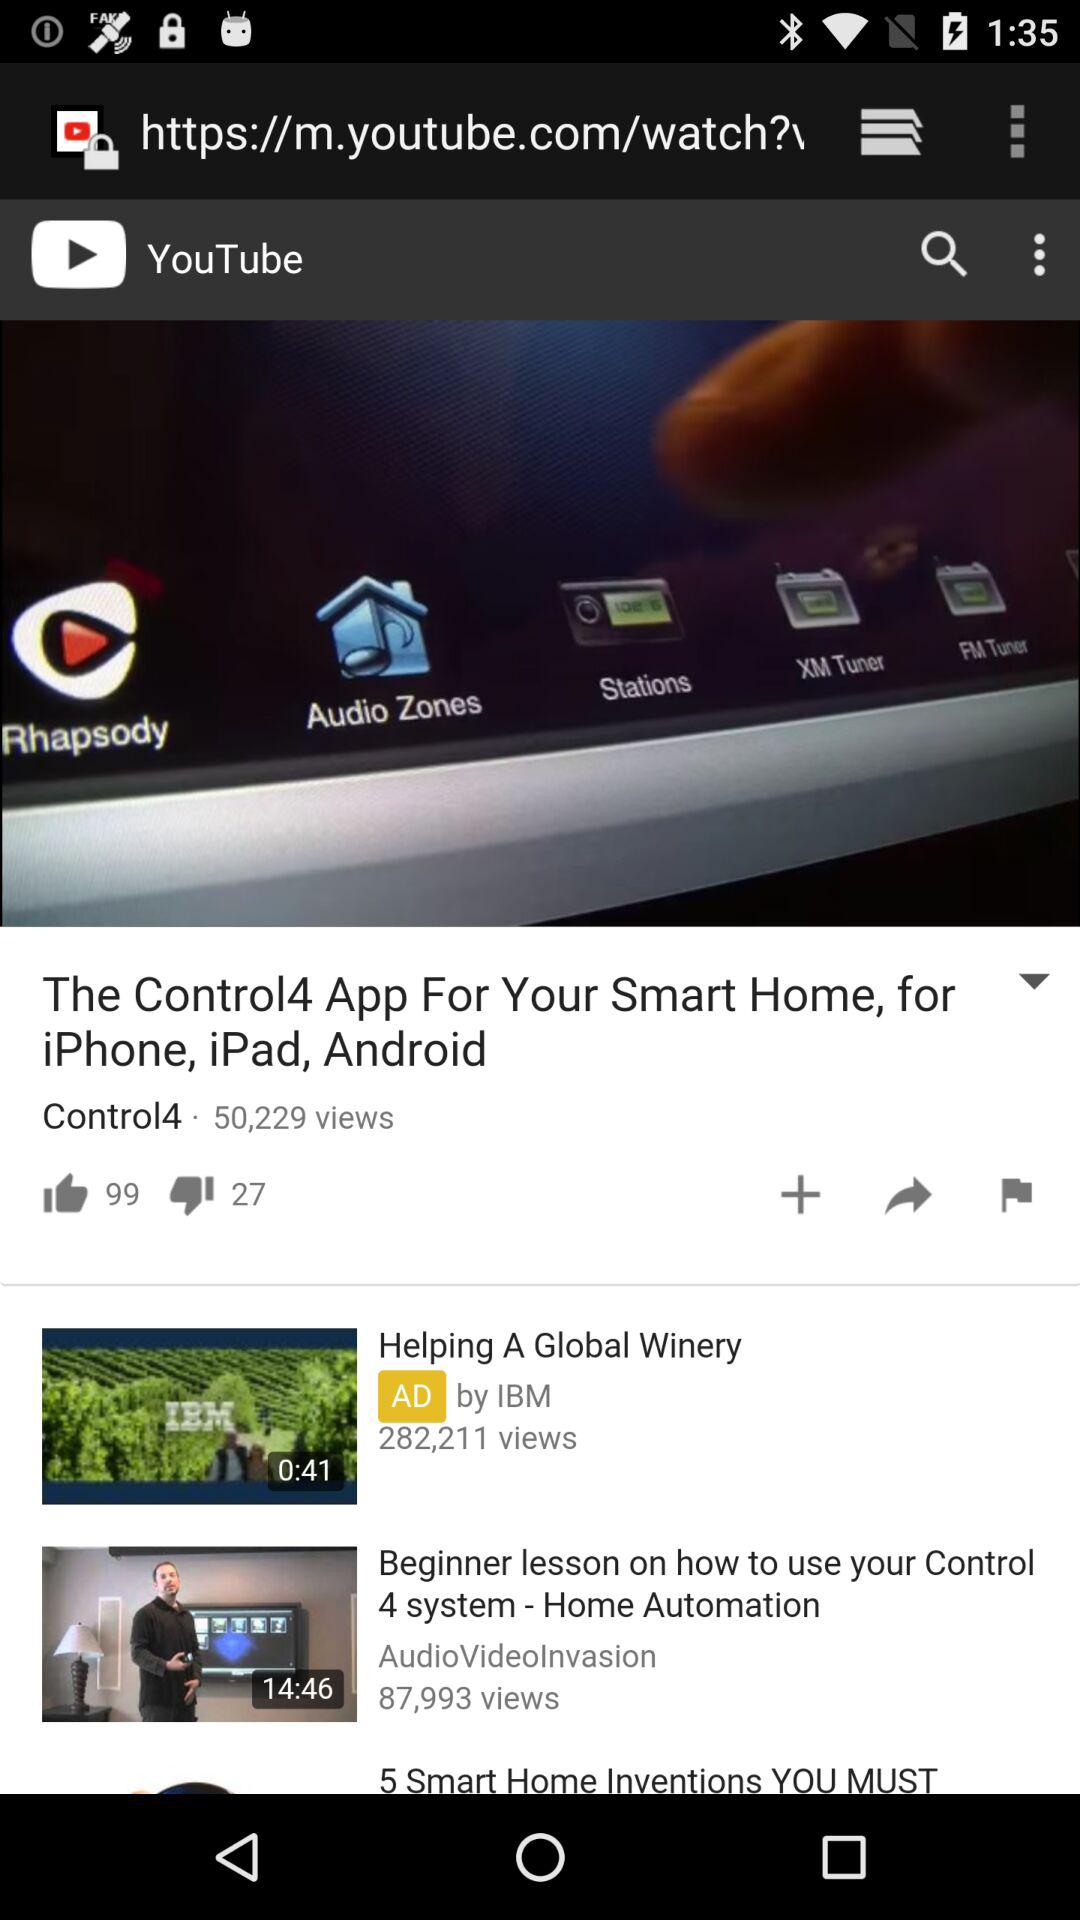How many dislikes are in the video? There are 27 dislikes in the video. 